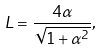Convert formula to latex. <formula><loc_0><loc_0><loc_500><loc_500>L = \frac { 4 \alpha } { \sqrt { 1 + \alpha ^ { 2 } } } ,</formula> 